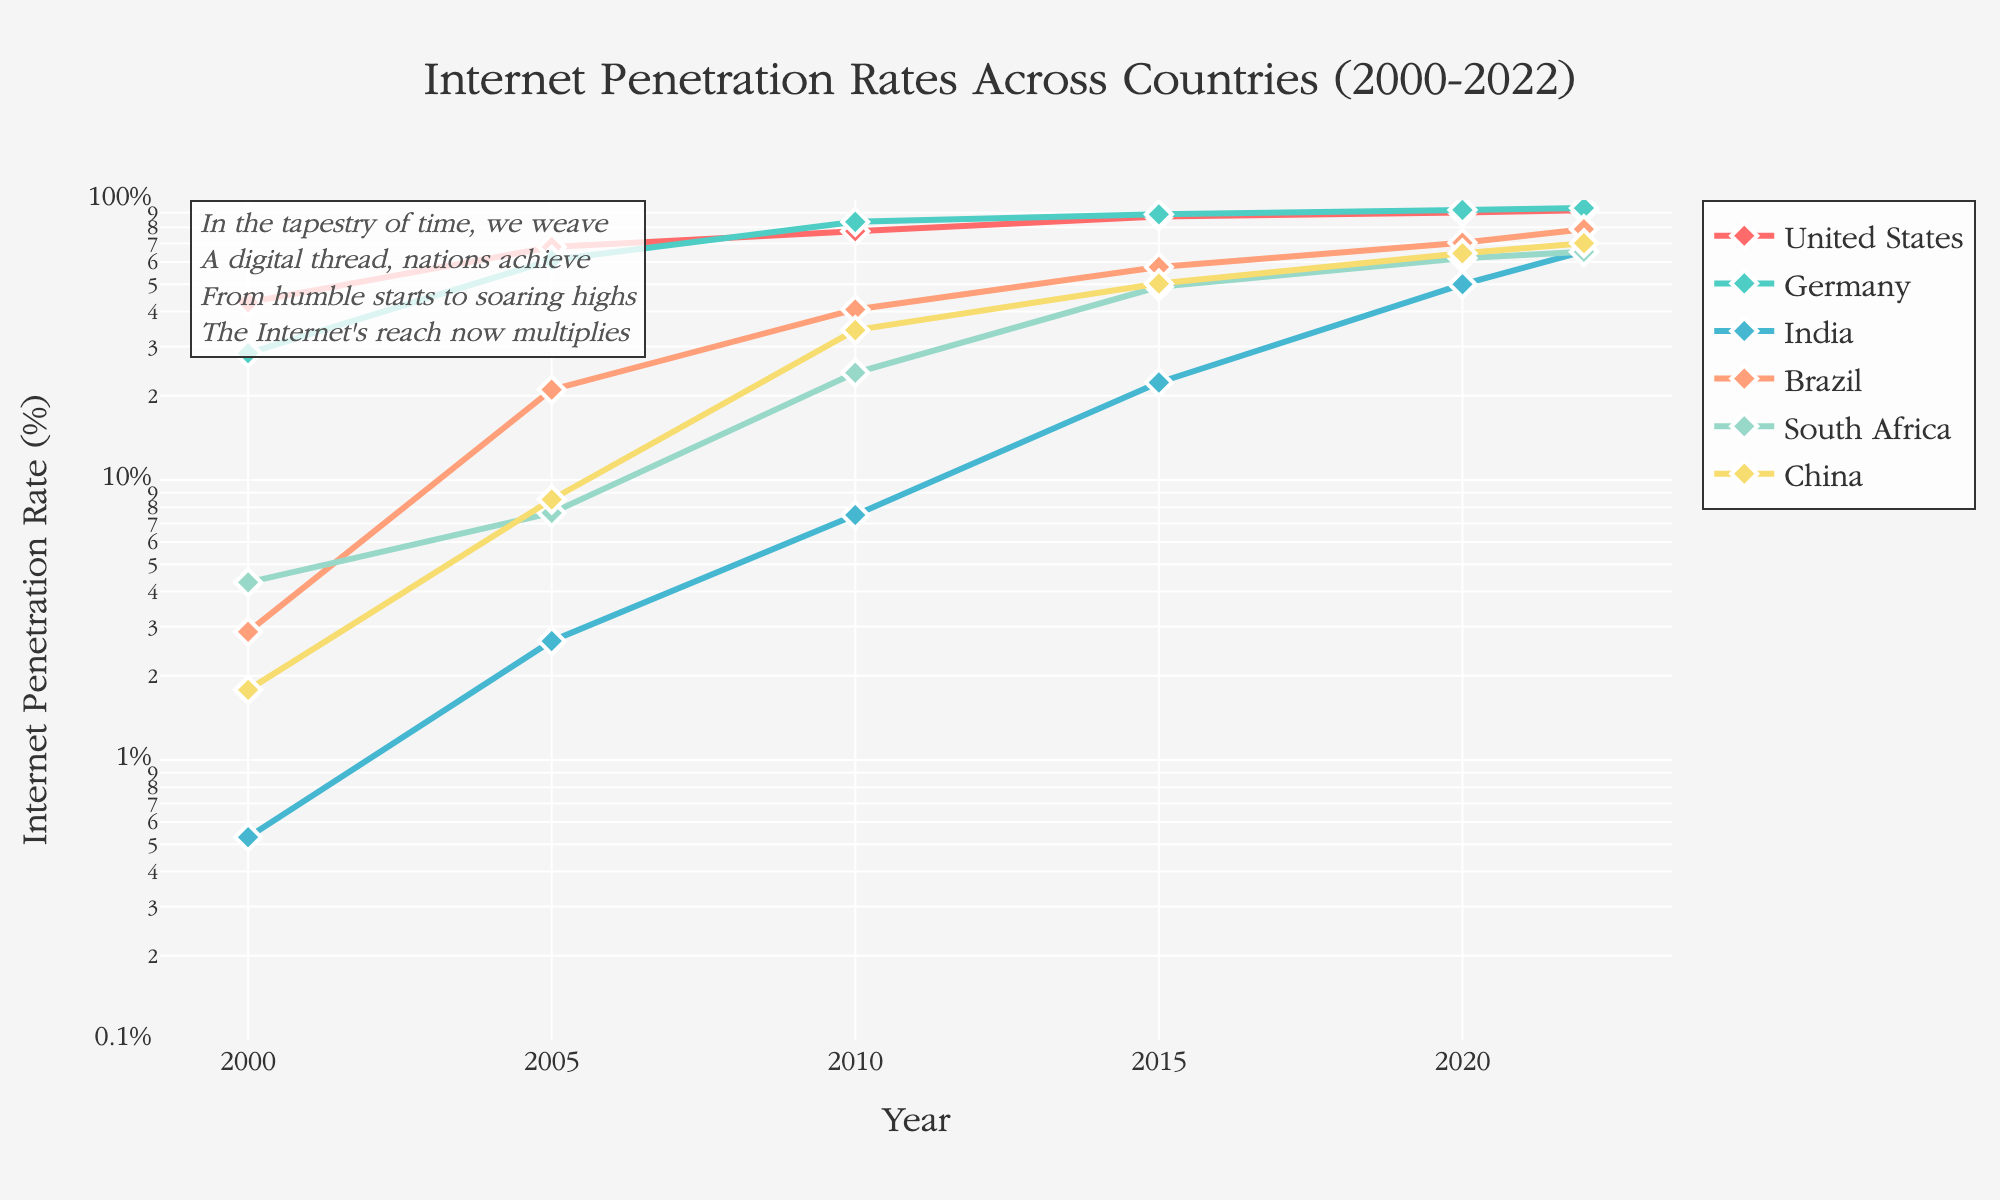what is the title of the figure? The title of the figure is located at the top center of the plot. It is often used to describe the overall content and purpose of the visualization. The title here clearly states that it is about Internet penetration rates across different countries from the year 2000 to 2022.
Answer: Internet Penetration Rates Across Countries (2000-2022) Which country had the lowest internet penetration rate in 2000? To find the lowest penetration rate in 2000, observe the data points along the y-axis for the year 2000. The markers closest to the bottom represent the lowest values. In this case, the country with a data point at around 0.53%.
Answer: India Among all countries, which experienced the highest growth in internet penetration rate from 2010 to 2020? To determine the highest growth, calculate the difference in internet penetration rates between 2010 and 2020 for each country. The difference is greatest for the country whose line shows the steepest upward slope during that period. India increased from 7.5% in 2010 to 50% in 2020.
Answer: India Which two countries had nearly the same internet penetration rate in 2022? Compare the data points at the year 2022 on the x-axis. Look for markers that are nearly at the same vertical position on the y-axis. Germany and the United States have almost similar rates (~93.6% and ~92%).
Answer: Germany and the United States How does the trend of internet penetration in China compare to that in the United States from 2000 to 2022? Compare the lines representing China and the United States. Both lines start relatively low but rise significantly. The U.S. shows a steadier and higher initial penetration and continues to grow, while China starts lower and increases sharply after 2005, catching up noticeably by 2022.
Answer: China's trend shows rapid increase after 2005, catching up with the U.S. by 2022 What is the y-axis scale, and why might this be chosen for this data set? The y-axis is on a logarithmic scale. This type of scale is useful for data spanning several orders of magnitude, like internet penetration rates starting from less than 1% and going up to over 90%. It helps to better visualize proportional growth.
Answer: Logarithmic scale, chosen for wide range data Which country had more than tenfold increase in internet penetration from 2000 to 2020? To determine this, check countries with more than 10 times increase from their initial values in 2000 to those in 2020. Calculate the ratio. For instance, India increased from 0.53% to 50%, which is well beyond tenfold.
Answer: India How many countries had an internet penetration rate of above 50% by 2015? Check the markers at the year 2015 and see which are above the 50% line. Count the markers that meet this criterion. The countries are the United States, Germany, Brazil, South Africa, and China, making it 5 countries.
Answer: 5 countries 